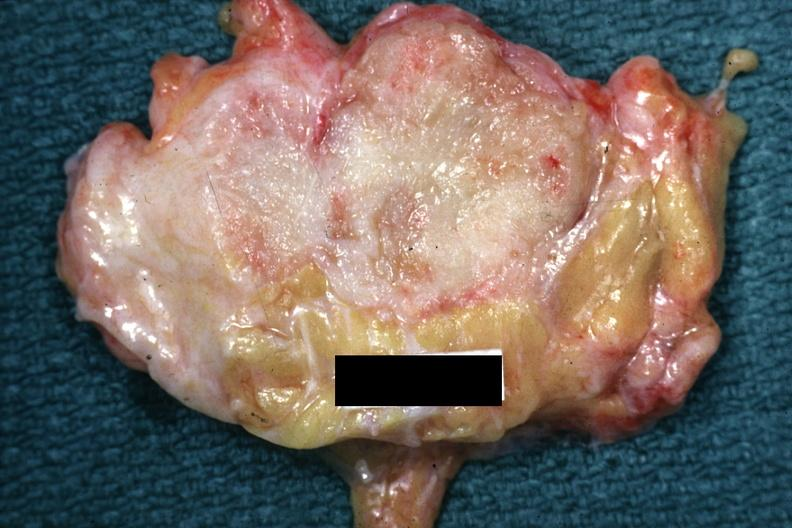does situs inversus appear too small for this?
Answer the question using a single word or phrase. No 